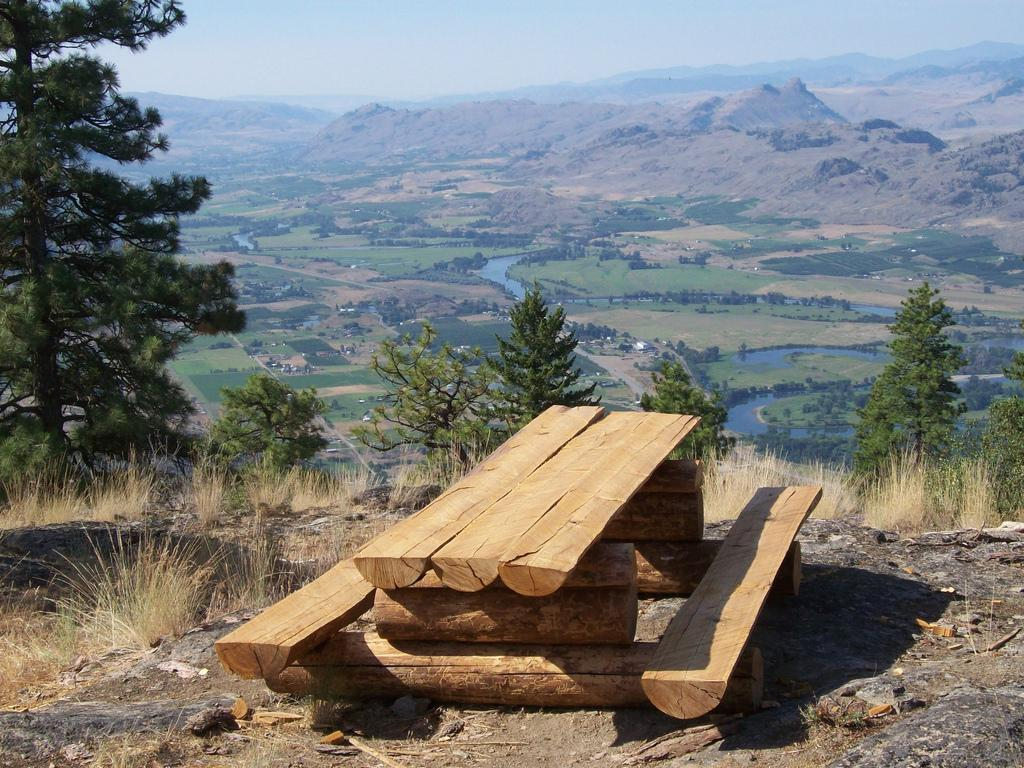What type of table is on the ground in the image? There is a wooden picnic table on the ground in the image. What type of vegetation is present in the image? Grass is present in the image. What other natural elements can be seen in the image? Trees and water are visible in the image. What is visible in the background of the image? There are hills and the sky visible in the background of the image. What type of circle is being ploughed in the image? There is no circle or ploughing activity present in the image. 